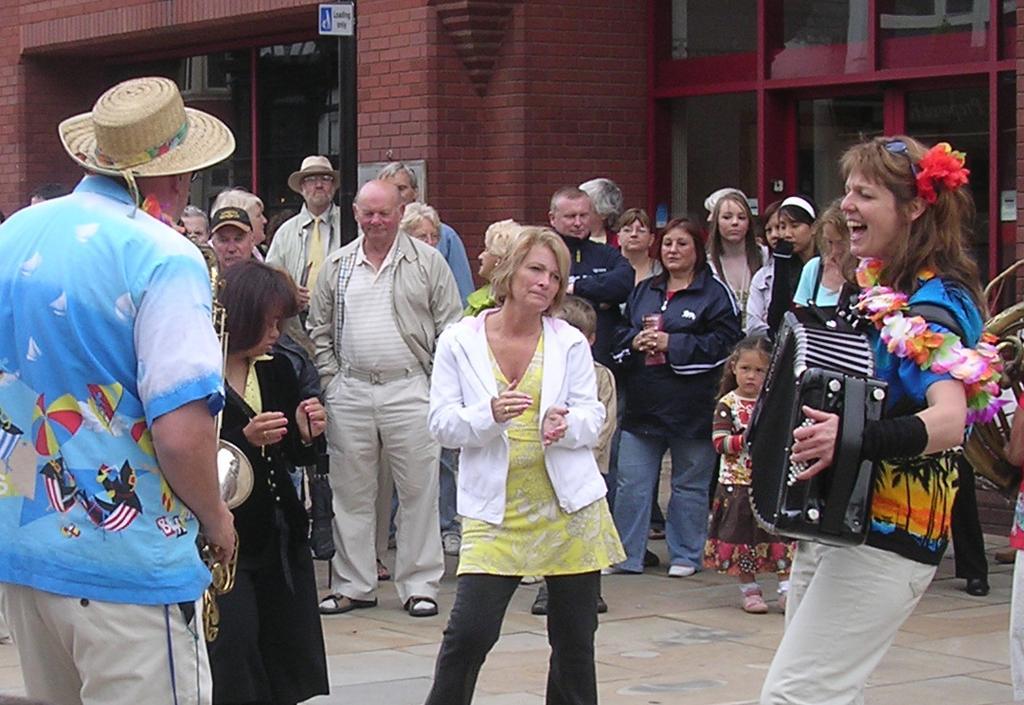Could you give a brief overview of what you see in this image? In this image two people are playing musical instruments. Many people are standing in front of them. They are watching both the persons. They are wearing summer dresses. This lady is singing as her mouth is open. In the background there is building. 